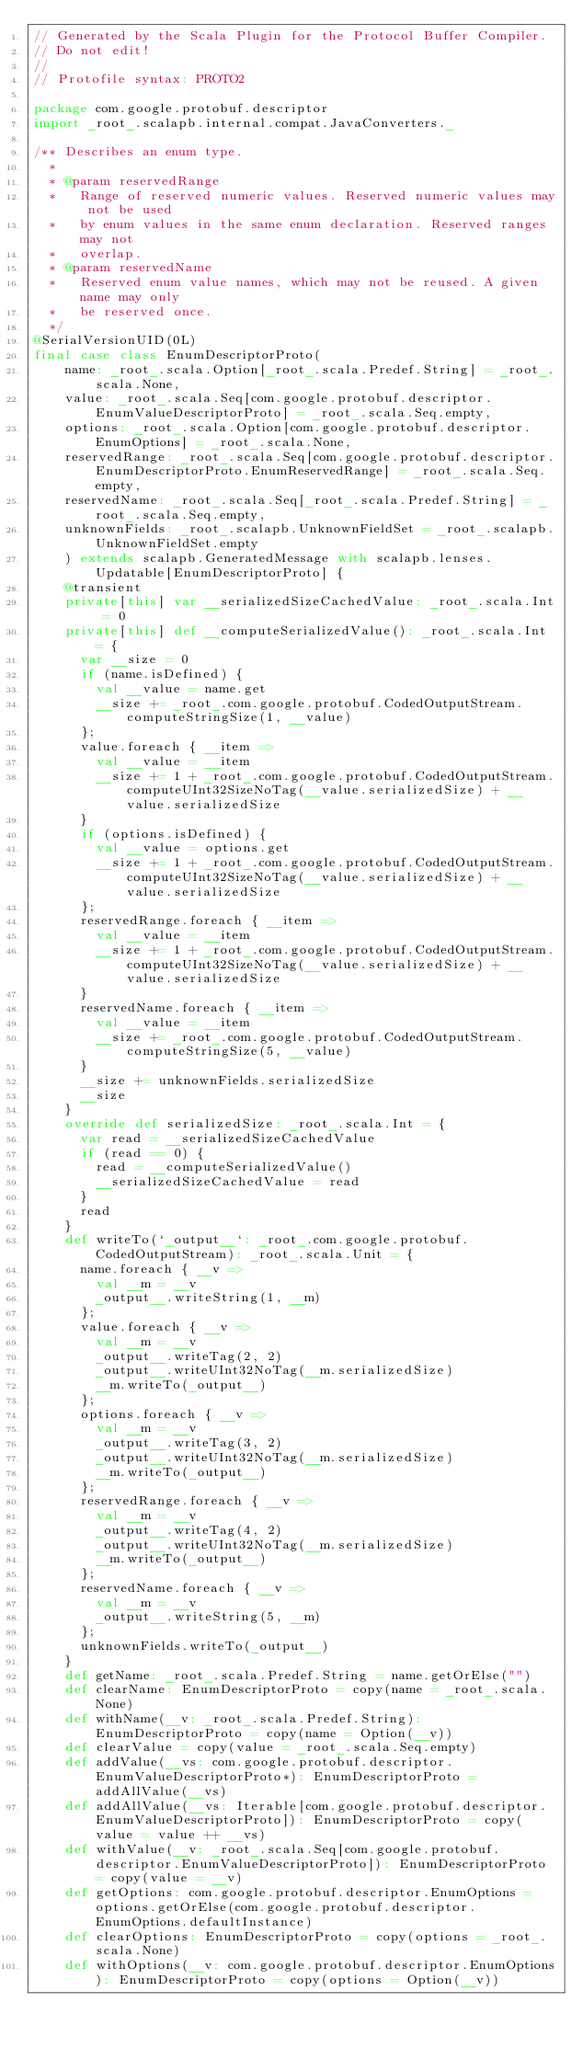Convert code to text. <code><loc_0><loc_0><loc_500><loc_500><_Scala_>// Generated by the Scala Plugin for the Protocol Buffer Compiler.
// Do not edit!
//
// Protofile syntax: PROTO2

package com.google.protobuf.descriptor
import _root_.scalapb.internal.compat.JavaConverters._

/** Describes an enum type.
  *
  * @param reservedRange
  *   Range of reserved numeric values. Reserved numeric values may not be used
  *   by enum values in the same enum declaration. Reserved ranges may not
  *   overlap.
  * @param reservedName
  *   Reserved enum value names, which may not be reused. A given name may only
  *   be reserved once.
  */
@SerialVersionUID(0L)
final case class EnumDescriptorProto(
    name: _root_.scala.Option[_root_.scala.Predef.String] = _root_.scala.None,
    value: _root_.scala.Seq[com.google.protobuf.descriptor.EnumValueDescriptorProto] = _root_.scala.Seq.empty,
    options: _root_.scala.Option[com.google.protobuf.descriptor.EnumOptions] = _root_.scala.None,
    reservedRange: _root_.scala.Seq[com.google.protobuf.descriptor.EnumDescriptorProto.EnumReservedRange] = _root_.scala.Seq.empty,
    reservedName: _root_.scala.Seq[_root_.scala.Predef.String] = _root_.scala.Seq.empty,
    unknownFields: _root_.scalapb.UnknownFieldSet = _root_.scalapb.UnknownFieldSet.empty
    ) extends scalapb.GeneratedMessage with scalapb.lenses.Updatable[EnumDescriptorProto] {
    @transient
    private[this] var __serializedSizeCachedValue: _root_.scala.Int = 0
    private[this] def __computeSerializedValue(): _root_.scala.Int = {
      var __size = 0
      if (name.isDefined) {
        val __value = name.get
        __size += _root_.com.google.protobuf.CodedOutputStream.computeStringSize(1, __value)
      };
      value.foreach { __item =>
        val __value = __item
        __size += 1 + _root_.com.google.protobuf.CodedOutputStream.computeUInt32SizeNoTag(__value.serializedSize) + __value.serializedSize
      }
      if (options.isDefined) {
        val __value = options.get
        __size += 1 + _root_.com.google.protobuf.CodedOutputStream.computeUInt32SizeNoTag(__value.serializedSize) + __value.serializedSize
      };
      reservedRange.foreach { __item =>
        val __value = __item
        __size += 1 + _root_.com.google.protobuf.CodedOutputStream.computeUInt32SizeNoTag(__value.serializedSize) + __value.serializedSize
      }
      reservedName.foreach { __item =>
        val __value = __item
        __size += _root_.com.google.protobuf.CodedOutputStream.computeStringSize(5, __value)
      }
      __size += unknownFields.serializedSize
      __size
    }
    override def serializedSize: _root_.scala.Int = {
      var read = __serializedSizeCachedValue
      if (read == 0) {
        read = __computeSerializedValue()
        __serializedSizeCachedValue = read
      }
      read
    }
    def writeTo(`_output__`: _root_.com.google.protobuf.CodedOutputStream): _root_.scala.Unit = {
      name.foreach { __v =>
        val __m = __v
        _output__.writeString(1, __m)
      };
      value.foreach { __v =>
        val __m = __v
        _output__.writeTag(2, 2)
        _output__.writeUInt32NoTag(__m.serializedSize)
        __m.writeTo(_output__)
      };
      options.foreach { __v =>
        val __m = __v
        _output__.writeTag(3, 2)
        _output__.writeUInt32NoTag(__m.serializedSize)
        __m.writeTo(_output__)
      };
      reservedRange.foreach { __v =>
        val __m = __v
        _output__.writeTag(4, 2)
        _output__.writeUInt32NoTag(__m.serializedSize)
        __m.writeTo(_output__)
      };
      reservedName.foreach { __v =>
        val __m = __v
        _output__.writeString(5, __m)
      };
      unknownFields.writeTo(_output__)
    }
    def getName: _root_.scala.Predef.String = name.getOrElse("")
    def clearName: EnumDescriptorProto = copy(name = _root_.scala.None)
    def withName(__v: _root_.scala.Predef.String): EnumDescriptorProto = copy(name = Option(__v))
    def clearValue = copy(value = _root_.scala.Seq.empty)
    def addValue(__vs: com.google.protobuf.descriptor.EnumValueDescriptorProto*): EnumDescriptorProto = addAllValue(__vs)
    def addAllValue(__vs: Iterable[com.google.protobuf.descriptor.EnumValueDescriptorProto]): EnumDescriptorProto = copy(value = value ++ __vs)
    def withValue(__v: _root_.scala.Seq[com.google.protobuf.descriptor.EnumValueDescriptorProto]): EnumDescriptorProto = copy(value = __v)
    def getOptions: com.google.protobuf.descriptor.EnumOptions = options.getOrElse(com.google.protobuf.descriptor.EnumOptions.defaultInstance)
    def clearOptions: EnumDescriptorProto = copy(options = _root_.scala.None)
    def withOptions(__v: com.google.protobuf.descriptor.EnumOptions): EnumDescriptorProto = copy(options = Option(__v))</code> 